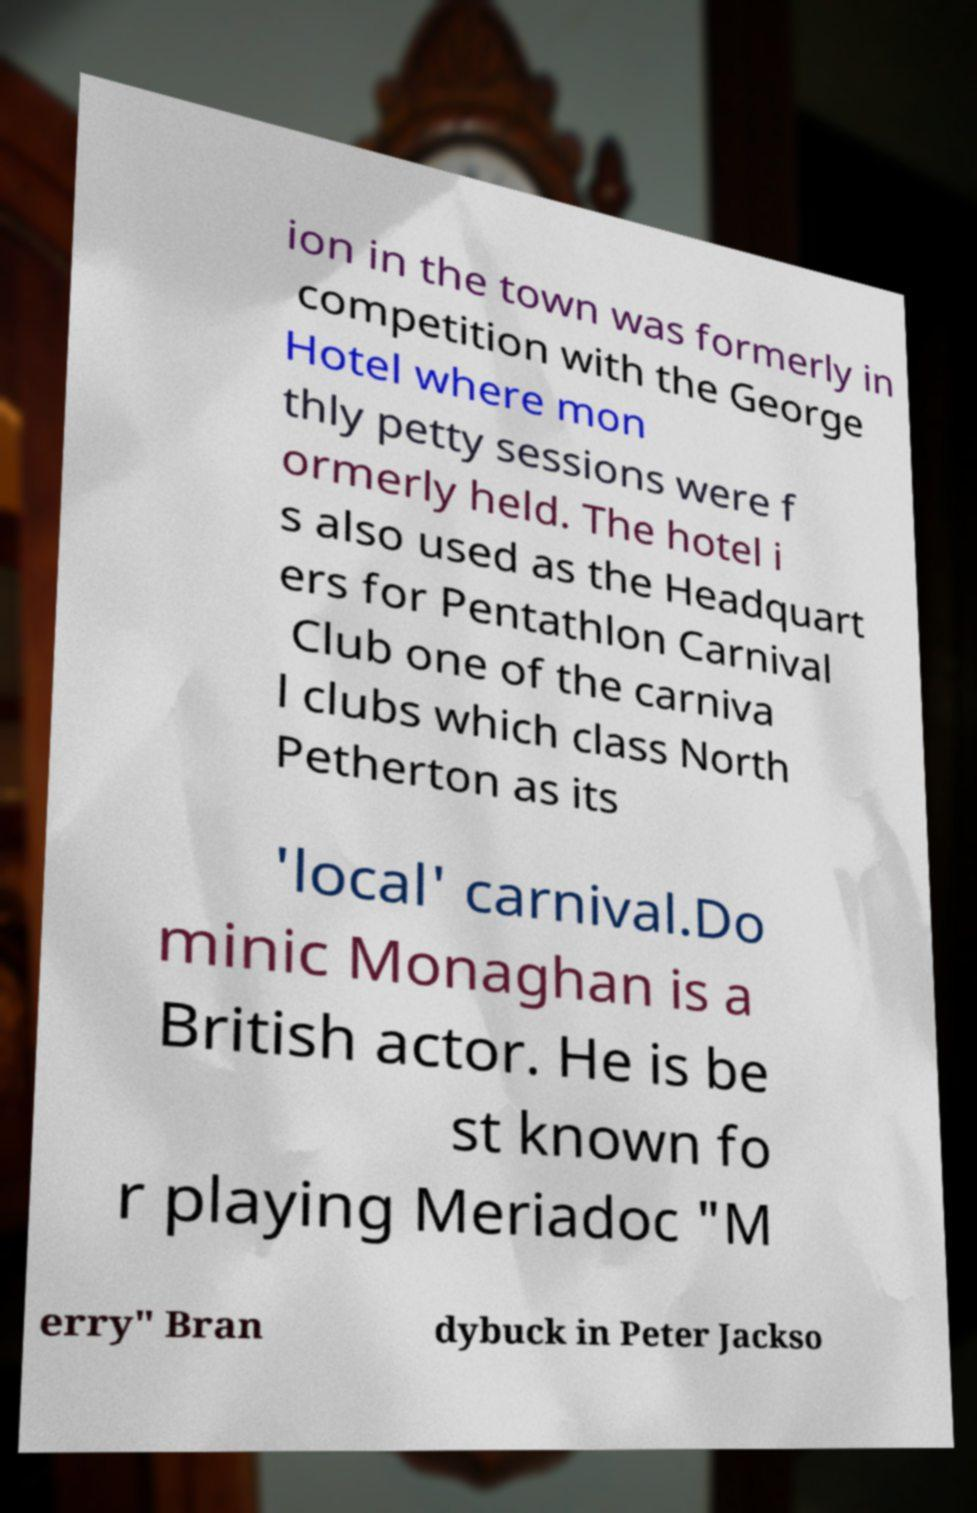Can you read and provide the text displayed in the image?This photo seems to have some interesting text. Can you extract and type it out for me? ion in the town was formerly in competition with the George Hotel where mon thly petty sessions were f ormerly held. The hotel i s also used as the Headquart ers for Pentathlon Carnival Club one of the carniva l clubs which class North Petherton as its 'local' carnival.Do minic Monaghan is a British actor. He is be st known fo r playing Meriadoc "M erry" Bran dybuck in Peter Jackso 